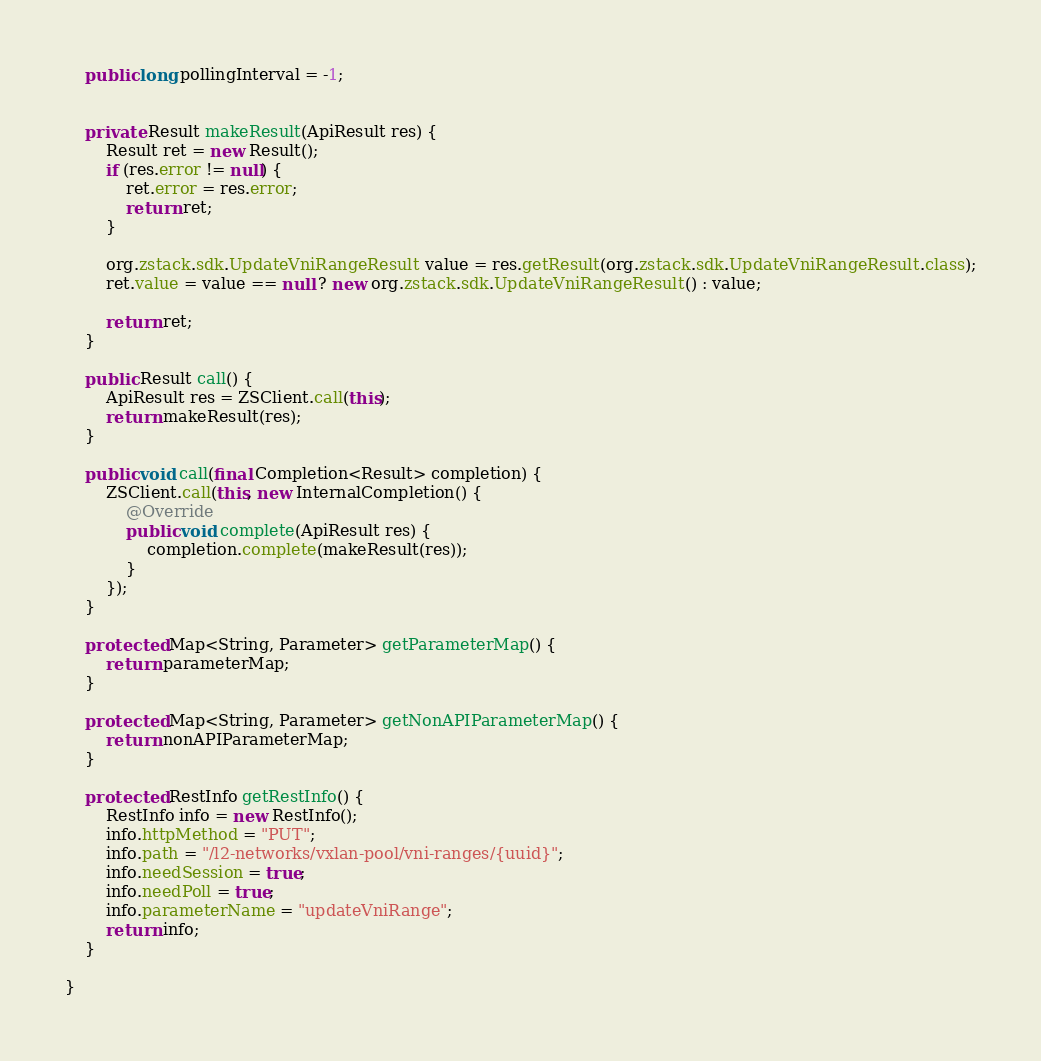<code> <loc_0><loc_0><loc_500><loc_500><_Java_>    public long pollingInterval = -1;


    private Result makeResult(ApiResult res) {
        Result ret = new Result();
        if (res.error != null) {
            ret.error = res.error;
            return ret;
        }
        
        org.zstack.sdk.UpdateVniRangeResult value = res.getResult(org.zstack.sdk.UpdateVniRangeResult.class);
        ret.value = value == null ? new org.zstack.sdk.UpdateVniRangeResult() : value; 

        return ret;
    }

    public Result call() {
        ApiResult res = ZSClient.call(this);
        return makeResult(res);
    }

    public void call(final Completion<Result> completion) {
        ZSClient.call(this, new InternalCompletion() {
            @Override
            public void complete(ApiResult res) {
                completion.complete(makeResult(res));
            }
        });
    }

    protected Map<String, Parameter> getParameterMap() {
        return parameterMap;
    }

    protected Map<String, Parameter> getNonAPIParameterMap() {
        return nonAPIParameterMap;
    }

    protected RestInfo getRestInfo() {
        RestInfo info = new RestInfo();
        info.httpMethod = "PUT";
        info.path = "/l2-networks/vxlan-pool/vni-ranges/{uuid}";
        info.needSession = true;
        info.needPoll = true;
        info.parameterName = "updateVniRange";
        return info;
    }

}
</code> 